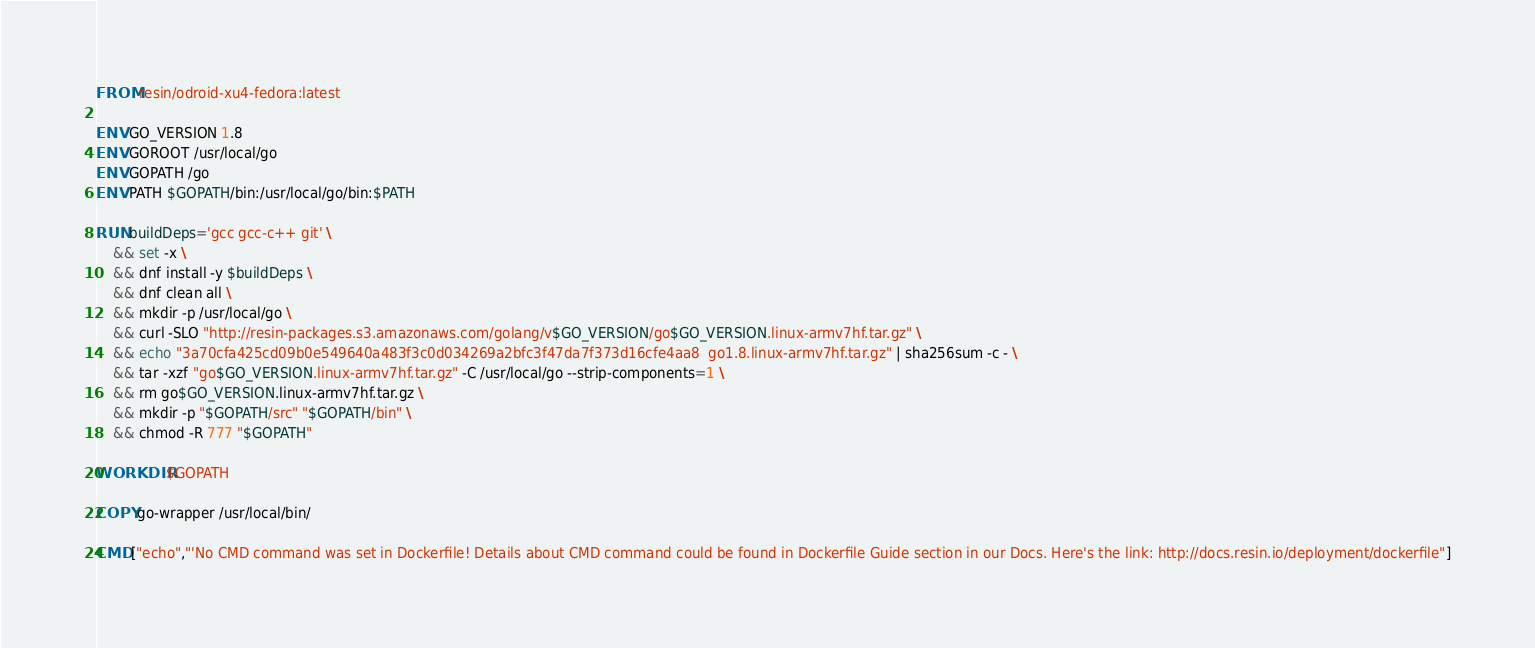<code> <loc_0><loc_0><loc_500><loc_500><_Dockerfile_>FROM resin/odroid-xu4-fedora:latest

ENV GO_VERSION 1.8
ENV GOROOT /usr/local/go
ENV GOPATH /go
ENV PATH $GOPATH/bin:/usr/local/go/bin:$PATH

RUN buildDeps='gcc gcc-c++ git' \
	&& set -x \
	&& dnf install -y $buildDeps \
	&& dnf clean all \
	&& mkdir -p /usr/local/go \
	&& curl -SLO "http://resin-packages.s3.amazonaws.com/golang/v$GO_VERSION/go$GO_VERSION.linux-armv7hf.tar.gz" \
	&& echo "3a70cfa425cd09b0e549640a483f3c0d034269a2bfc3f47da7f373d16cfe4aa8  go1.8.linux-armv7hf.tar.gz" | sha256sum -c - \
	&& tar -xzf "go$GO_VERSION.linux-armv7hf.tar.gz" -C /usr/local/go --strip-components=1 \
	&& rm go$GO_VERSION.linux-armv7hf.tar.gz \
	&& mkdir -p "$GOPATH/src" "$GOPATH/bin" \
	&& chmod -R 777 "$GOPATH"

WORKDIR $GOPATH

COPY go-wrapper /usr/local/bin/

CMD ["echo","'No CMD command was set in Dockerfile! Details about CMD command could be found in Dockerfile Guide section in our Docs. Here's the link: http://docs.resin.io/deployment/dockerfile"]
</code> 